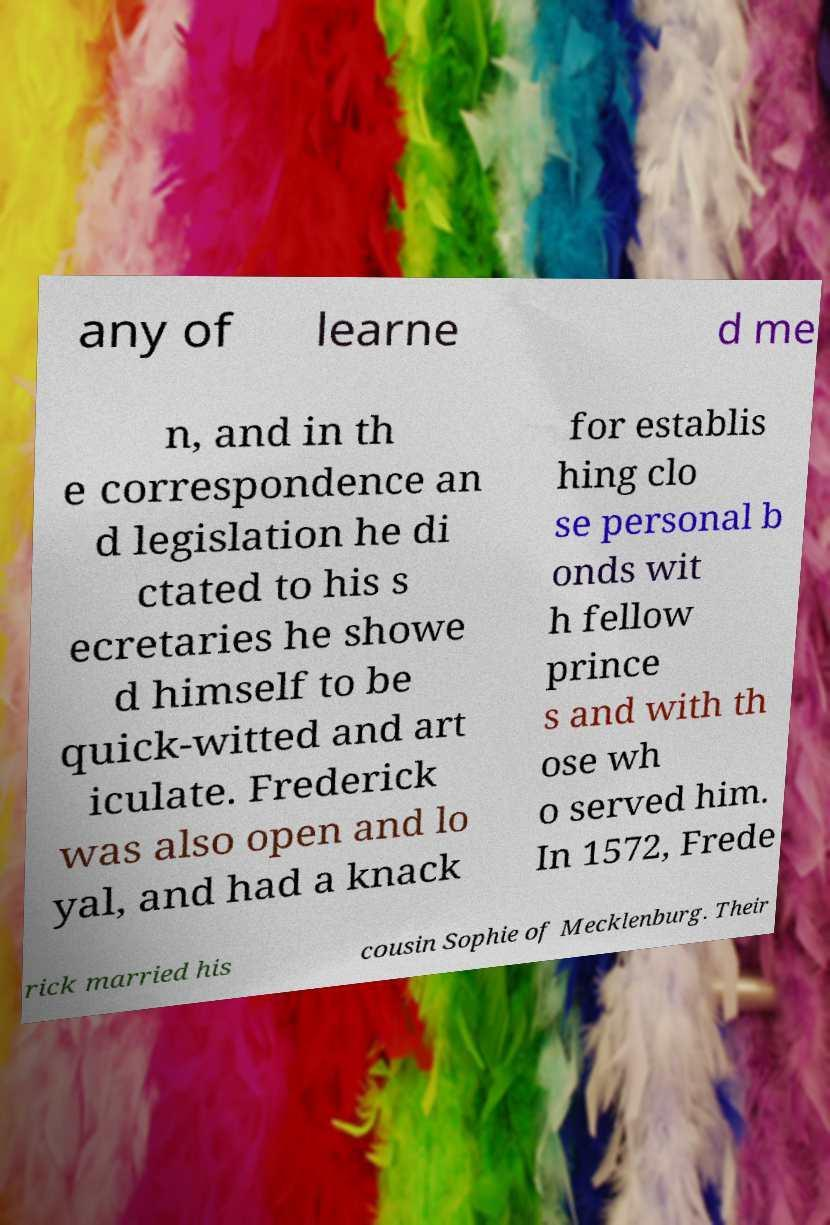Can you accurately transcribe the text from the provided image for me? any of learne d me n, and in th e correspondence an d legislation he di ctated to his s ecretaries he showe d himself to be quick-witted and art iculate. Frederick was also open and lo yal, and had a knack for establis hing clo se personal b onds wit h fellow prince s and with th ose wh o served him. In 1572, Frede rick married his cousin Sophie of Mecklenburg. Their 